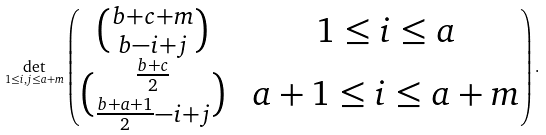Convert formula to latex. <formula><loc_0><loc_0><loc_500><loc_500>\det _ { 1 \leq i , j \leq a + m } \begin{pmatrix} \binom { b + c + m } { b - i + j } & \text { $1\leq i\leq a$} \\ \binom { \frac { b + c } { 2 } } { \frac { b + a + 1 } { 2 } - i + j } & \text { $a+1\leq i \leq a+m$} \end{pmatrix} .</formula> 